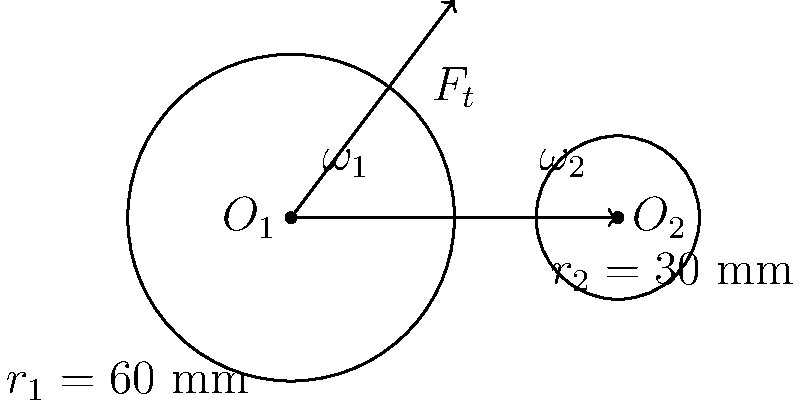In the simple gear train shown, gear 1 rotates clockwise at 300 rpm and has 40 teeth. Gear 2 has 20 teeth. If the power transmitted is 2 kW, calculate the tangential force $F_t$ acting on the gear teeth. Let's approach this step-by-step:

1) First, we need to calculate the angular velocity of gear 1 in rad/s:
   $\omega_1 = 300 \text{ rpm} \times \frac{2\pi}{60} = 10\pi \text{ rad/s}$

2) The gear ratio is:
   $\frac{\omega_1}{\omega_2} = \frac{N_2}{N_1} = \frac{20}{40} = \frac{1}{2}$

3) So, $\omega_2 = 2\omega_1 = 20\pi \text{ rad/s}$

4) The radius of gear 1 is given as 60 mm = 0.06 m

5) Power is related to torque and angular velocity by:
   $P = T\omega$

6) The torque on gear 1 is:
   $T_1 = \frac{P}{\omega_1} = \frac{2000}{10\pi} = \frac{200}{\pi} \text{ N⋅m}$

7) The tangential force is related to torque and radius by:
   $F_t = \frac{T}{r}$

8) Therefore:
   $F_t = \frac{200/\pi}{0.06} = \frac{10000}{3\pi} \text{ N} \approx 1061 \text{ N}$
Answer: $F_t \approx 1061 \text{ N}$ 